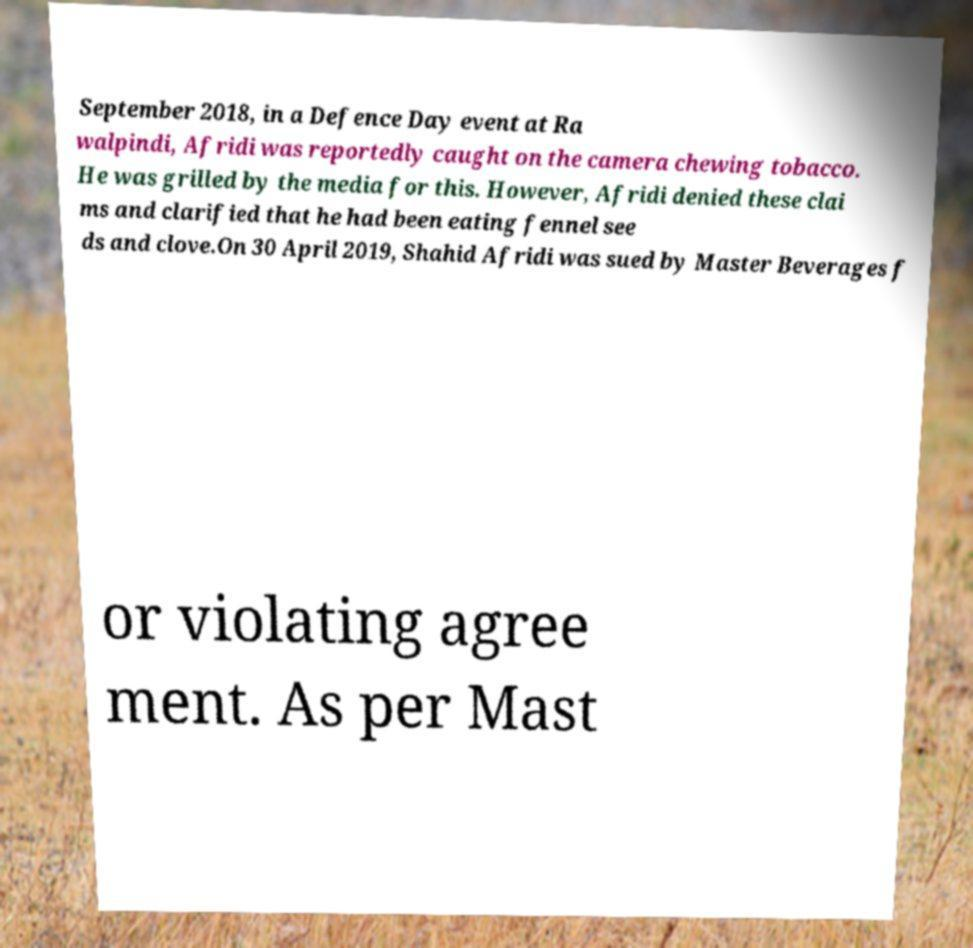Could you extract and type out the text from this image? September 2018, in a Defence Day event at Ra walpindi, Afridi was reportedly caught on the camera chewing tobacco. He was grilled by the media for this. However, Afridi denied these clai ms and clarified that he had been eating fennel see ds and clove.On 30 April 2019, Shahid Afridi was sued by Master Beverages f or violating agree ment. As per Mast 